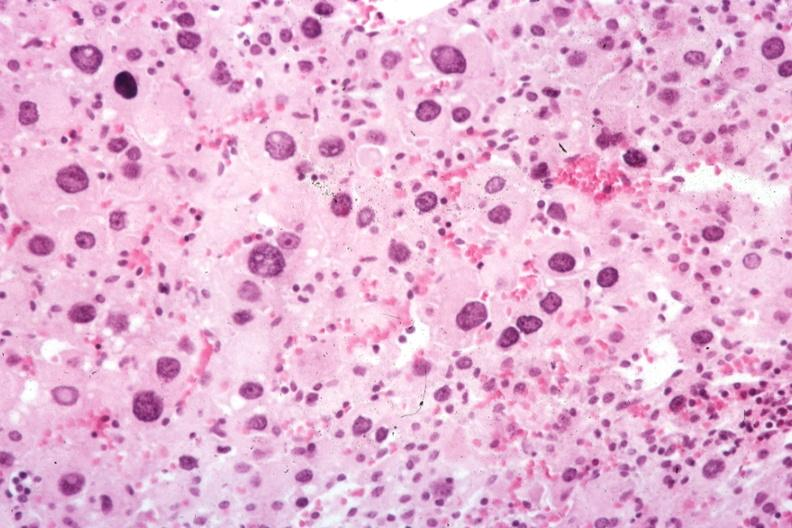where is this part in the figure?
Answer the question using a single word or phrase. Endocrine system 